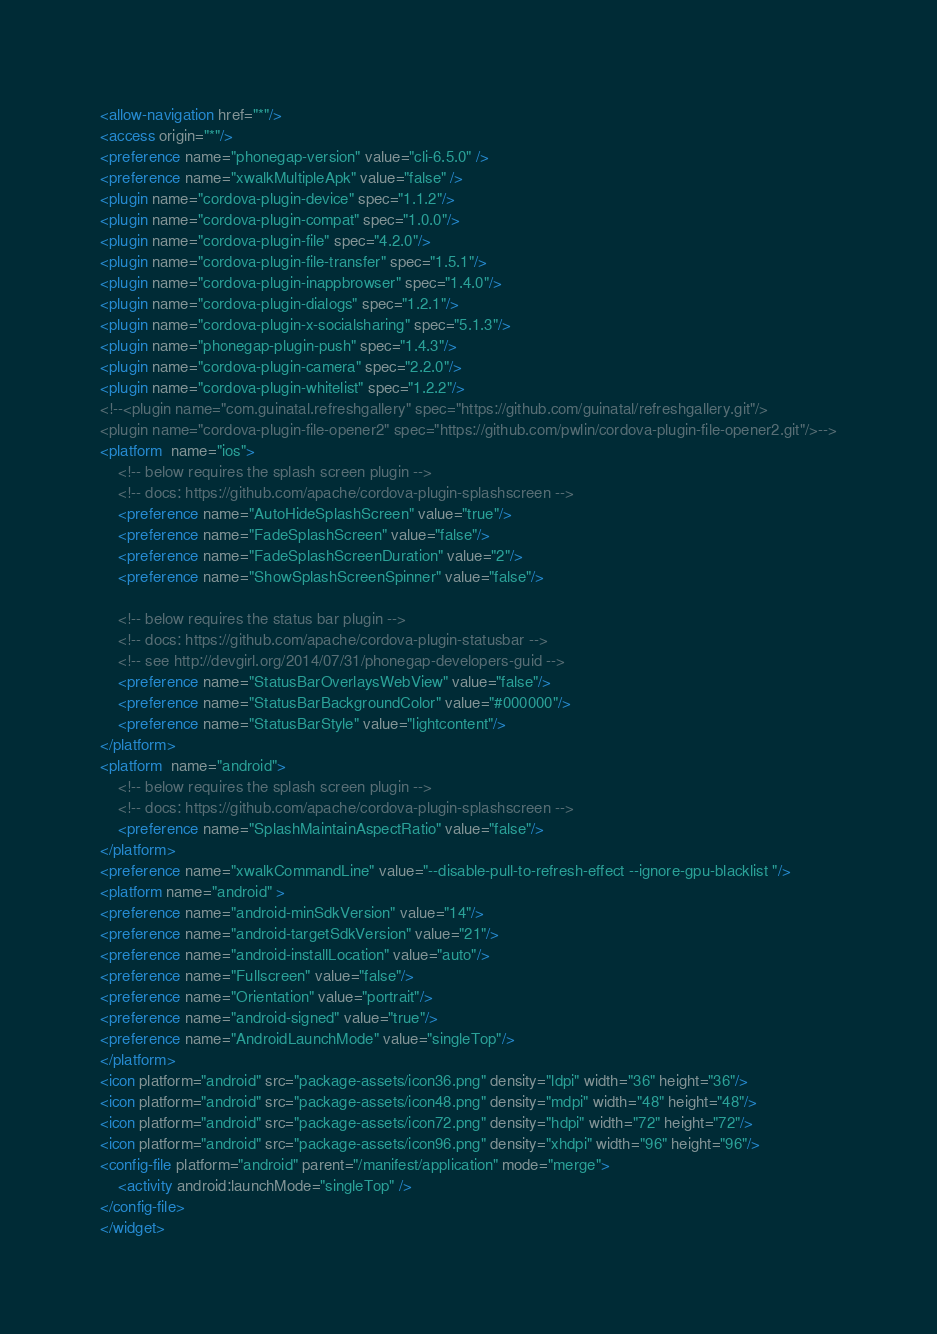Convert code to text. <code><loc_0><loc_0><loc_500><loc_500><_XML_><allow-navigation href="*"/>
<access origin="*"/>
<preference name="phonegap-version" value="cli-6.5.0" />
<preference name="xwalkMultipleApk" value="false" />
<plugin name="cordova-plugin-device" spec="1.1.2"/>
<plugin name="cordova-plugin-compat" spec="1.0.0"/>
<plugin name="cordova-plugin-file" spec="4.2.0"/>
<plugin name="cordova-plugin-file-transfer" spec="1.5.1"/>
<plugin name="cordova-plugin-inappbrowser" spec="1.4.0"/>
<plugin name="cordova-plugin-dialogs" spec="1.2.1"/>
<plugin name="cordova-plugin-x-socialsharing" spec="5.1.3"/>
<plugin name="phonegap-plugin-push" spec="1.4.3"/>
<plugin name="cordova-plugin-camera" spec="2.2.0"/>
<plugin name="cordova-plugin-whitelist" spec="1.2.2"/>
<!--<plugin name="com.guinatal.refreshgallery" spec="https://github.com/guinatal/refreshgallery.git"/>
<plugin name="cordova-plugin-file-opener2" spec="https://github.com/pwlin/cordova-plugin-file-opener2.git"/>-->
<platform  name="ios">
    <!-- below requires the splash screen plugin -->
    <!-- docs: https://github.com/apache/cordova-plugin-splashscreen -->
    <preference name="AutoHideSplashScreen" value="true"/>
    <preference name="FadeSplashScreen" value="false"/>
    <preference name="FadeSplashScreenDuration" value="2"/>
    <preference name="ShowSplashScreenSpinner" value="false"/>

    <!-- below requires the status bar plugin -->
    <!-- docs: https://github.com/apache/cordova-plugin-statusbar -->
    <!-- see http://devgirl.org/2014/07/31/phonegap-developers-guid -->
    <preference name="StatusBarOverlaysWebView" value="false"/>
    <preference name="StatusBarBackgroundColor" value="#000000"/>
    <preference name="StatusBarStyle" value="lightcontent"/>
</platform>
<platform  name="android">
    <!-- below requires the splash screen plugin -->
    <!-- docs: https://github.com/apache/cordova-plugin-splashscreen -->
    <preference name="SplashMaintainAspectRatio" value="false"/>
</platform>
<preference name="xwalkCommandLine" value="--disable-pull-to-refresh-effect --ignore-gpu-blacklist "/>
<platform name="android" >
<preference name="android-minSdkVersion" value="14"/>
<preference name="android-targetSdkVersion" value="21"/>
<preference name="android-installLocation" value="auto"/>
<preference name="Fullscreen" value="false"/>
<preference name="Orientation" value="portrait"/>
<preference name="android-signed" value="true"/>
<preference name="AndroidLaunchMode" value="singleTop"/>
</platform>
<icon platform="android" src="package-assets/icon36.png" density="ldpi" width="36" height="36"/>
<icon platform="android" src="package-assets/icon48.png" density="mdpi" width="48" height="48"/>
<icon platform="android" src="package-assets/icon72.png" density="hdpi" width="72" height="72"/>
<icon platform="android" src="package-assets/icon96.png" density="xhdpi" width="96" height="96"/>
<config-file platform="android" parent="/manifest/application" mode="merge"> 
    <activity android:launchMode="singleTop" />
</config-file>
</widget>
</code> 